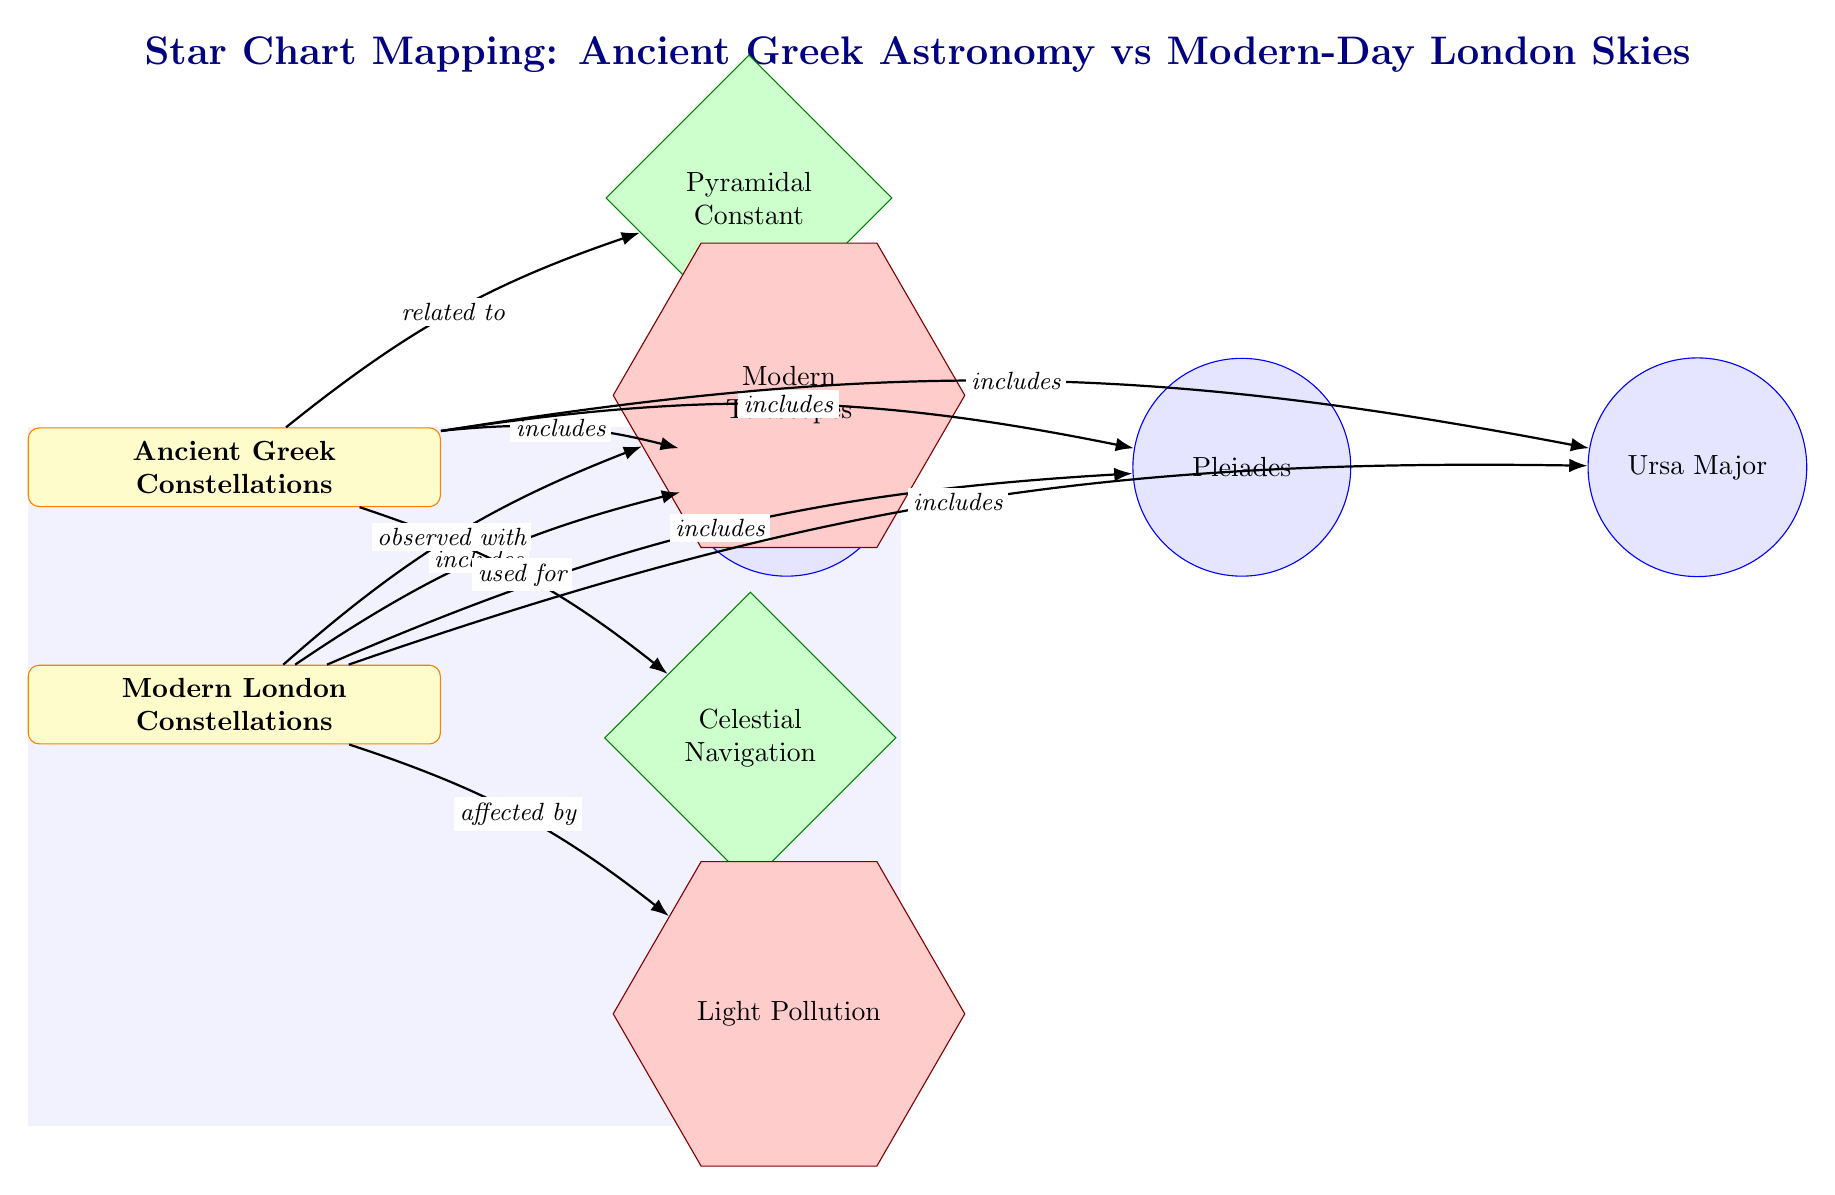What are the two main categories in the diagram? The diagram has two main categories: "Ancient Greek Constellations" and "Modern London Constellations" labeled at the top.
Answer: Ancient Greek Constellations, Modern London Constellations How many constellations are listed in the diagram? The diagram shows three constellations, which are Orion, Pleiades, and Ursa Major, all connected to the categories.
Answer: 3 What relationship does the Pyramidal Constant have with Ancient Greek? The diagram indicates that the Pyramidal Constant is "related to" Ancient Greek Constellations, as shown by the directed edge connecting these two nodes.
Answer: related to Which modern instrument is listed for observing constellations? The diagram lists "Modern Telescopes" as the modern instrument involved with the Modern London Constellations, identified by the directed edge from the Modern category.
Answer: Modern Telescopes What effect does light pollution have on modern stargazing? The diagram shows that light pollution is "affected by" Modern London Constellations, underlining its impact on observing the stars in the modern context.
Answer: affected by Which ancient Greek element is linked to celestial navigation? According to the diagram, "Celestial Navigation" is connected to Ancient Greek Constellations, indicating its importance in ancient practice for navigation.
Answer: used for What kind of connection exists between the constellations and the categories in the diagram? The diagram depicts that the constellations are included in both Ancient Greek and Modern categories, showing that each category encompasses shared constellations like Orion.
Answer: includes What unique aspect does the diagram illustrate about Ancient Greek Astronomy compared to Modern London? The diagram outlines different utilization for Ancient Greek Astronomy, emphasizing concepts like Pyramidal Constant while also highlighting the influence of modern technology and challenges like pollution on London skies.
Answer: unique aspect 